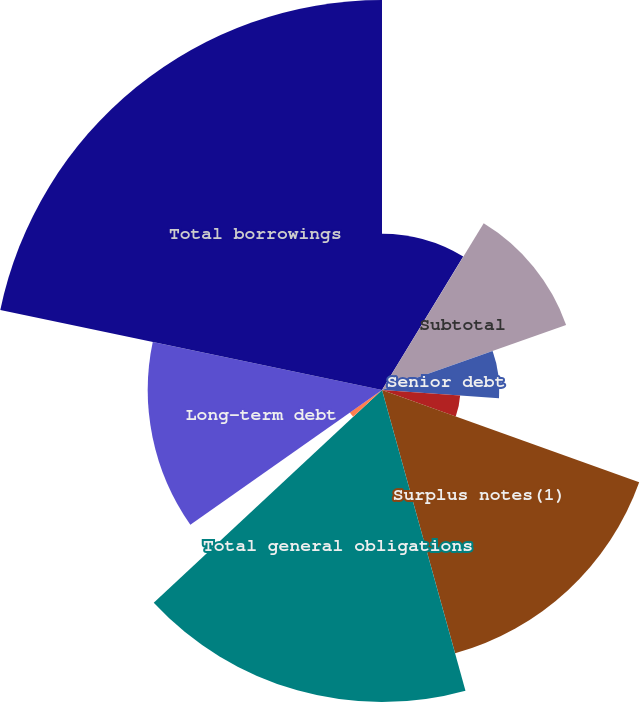<chart> <loc_0><loc_0><loc_500><loc_500><pie_chart><fcel>Commercial paper<fcel>Current portion of long-term<fcel>Subtotal<fcel>Senior debt<fcel>Junior subordinated debt<fcel>Surplus notes(1)<fcel>Total general obligations<fcel>Short-term debt<fcel>Long-term debt<fcel>Total borrowings<nl><fcel>8.7%<fcel>0.02%<fcel>10.87%<fcel>6.53%<fcel>4.36%<fcel>15.21%<fcel>17.37%<fcel>2.19%<fcel>13.04%<fcel>21.71%<nl></chart> 